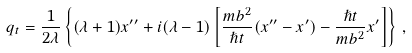<formula> <loc_0><loc_0><loc_500><loc_500>q _ { t } = \frac { 1 } { 2 \lambda } \left \{ ( \lambda + 1 ) x ^ { \prime \prime } + i ( \lambda - 1 ) \left [ \frac { m b ^ { 2 } } { \hslash t } ( x ^ { \prime \prime } - x ^ { \prime } ) - \frac { \hslash t } { m b ^ { 2 } } x ^ { \prime } \right ] \right \} \, ,</formula> 